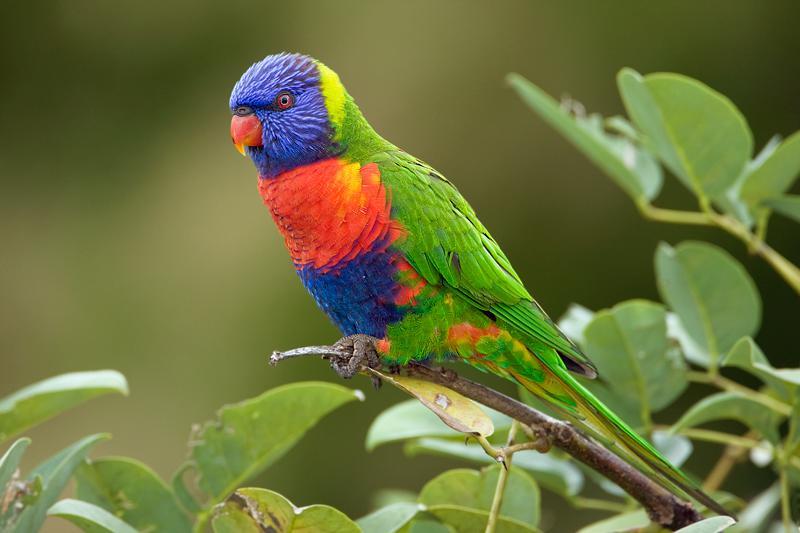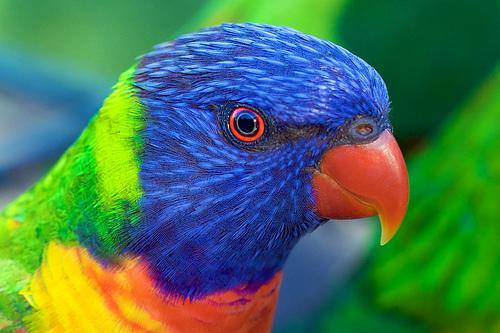The first image is the image on the left, the second image is the image on the right. Given the left and right images, does the statement "At least one parrot is perched on a human hand." hold true? Answer yes or no. No. The first image is the image on the left, the second image is the image on the right. Examine the images to the left and right. Is the description "The left image contains at least two parrots." accurate? Answer yes or no. No. 